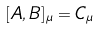Convert formula to latex. <formula><loc_0><loc_0><loc_500><loc_500>[ A , B ] _ { \mu } = C _ { \mu }</formula> 